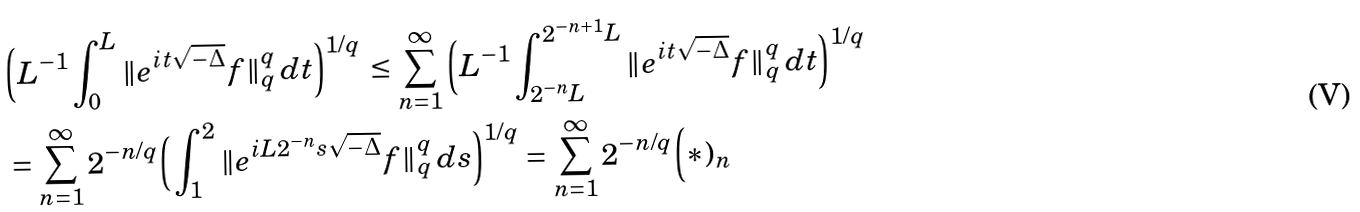<formula> <loc_0><loc_0><loc_500><loc_500>& \Big ( L ^ { - 1 } \int _ { 0 } ^ { L } \| e ^ { i t \sqrt { - \Delta } } f \| _ { q } ^ { q } \, d t \Big ) ^ { 1 / q } \, \leq \sum _ { n = 1 } ^ { \infty } \Big ( L ^ { - 1 } \int _ { 2 ^ { - n } L } ^ { 2 ^ { - n + 1 } L } \| e ^ { i t \sqrt { - \Delta } } f \| _ { q } ^ { q } \, d t \Big ) ^ { 1 / q } \\ & = \sum _ { n = 1 } ^ { \infty } 2 ^ { - n / q } \Big ( \int _ { 1 } ^ { 2 } \| e ^ { i L 2 ^ { - n } s \sqrt { - \Delta } } f \| _ { q } ^ { q } \, d s \Big ) ^ { 1 / q } = \sum _ { n = 1 } ^ { \infty } 2 ^ { - n / q } \Big ( * ) _ { n }</formula> 